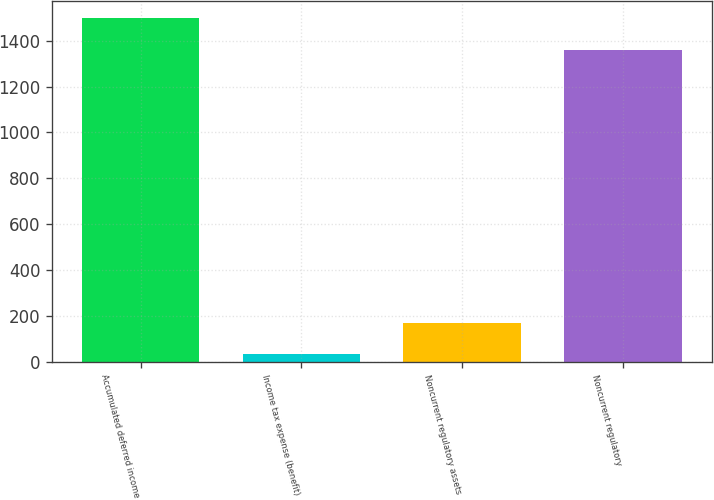Convert chart to OTSL. <chart><loc_0><loc_0><loc_500><loc_500><bar_chart><fcel>Accumulated deferred income<fcel>Income tax expense (benefit)<fcel>Noncurrent regulatory assets<fcel>Noncurrent regulatory<nl><fcel>1500.7<fcel>32<fcel>170.7<fcel>1362<nl></chart> 